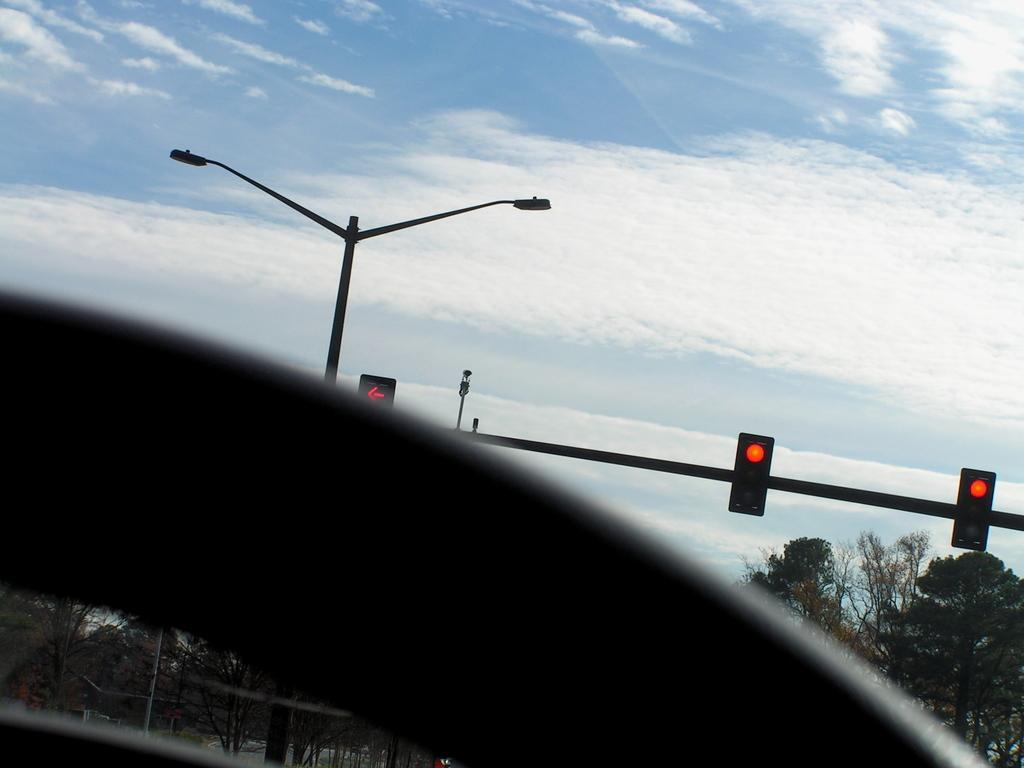What is located at the bottom of the image? There is an object at the bottom of the image. What can be seen in the background of the image? There are traffic signal poles, trees, street lights, and poles in the background of the image. What is visible in the sky in the background of the image? There are clouds in the sky in the background of the image. What type of bait is being used by the parent in the image? There is no bait or parent present in the image. How is the waste being disposed of in the image? There is no waste present in the image. 